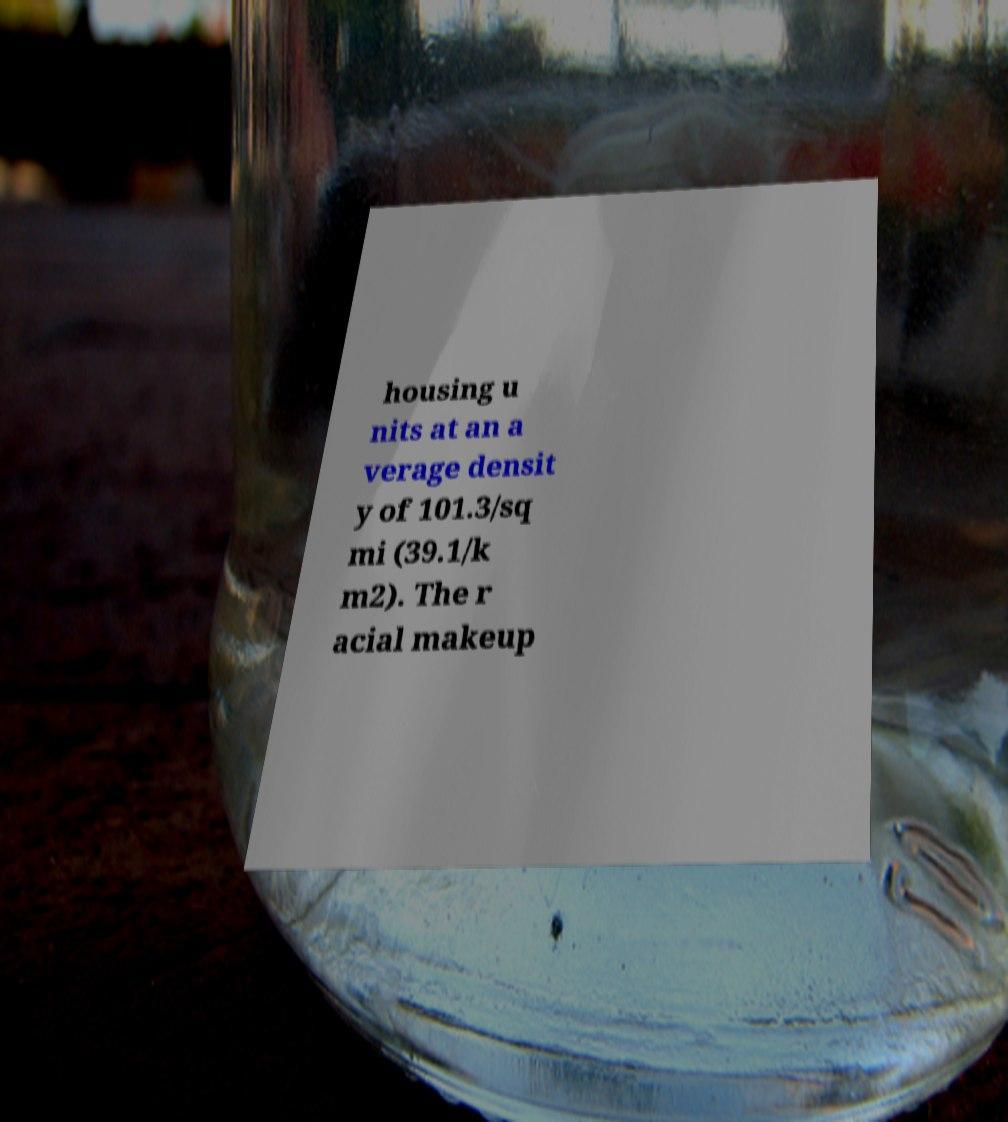For documentation purposes, I need the text within this image transcribed. Could you provide that? housing u nits at an a verage densit y of 101.3/sq mi (39.1/k m2). The r acial makeup 